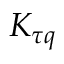Convert formula to latex. <formula><loc_0><loc_0><loc_500><loc_500>K _ { \tau q }</formula> 